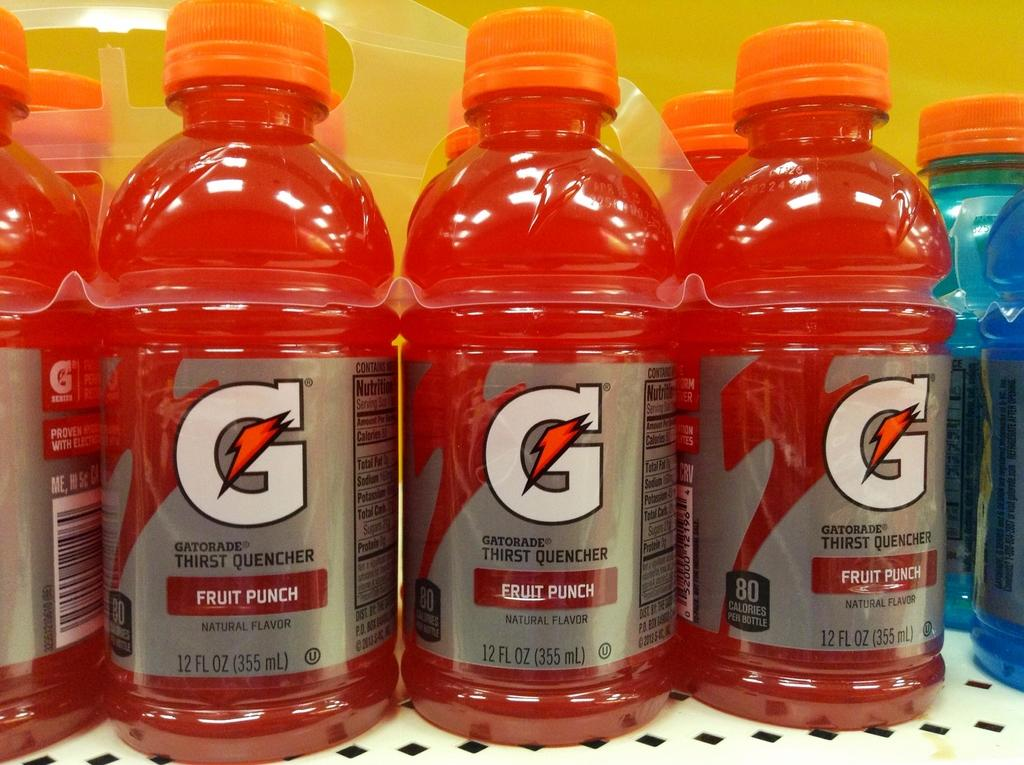<image>
Relay a brief, clear account of the picture shown. A multi-pack of Fruit Punch Gatorade rests on a shelf. 